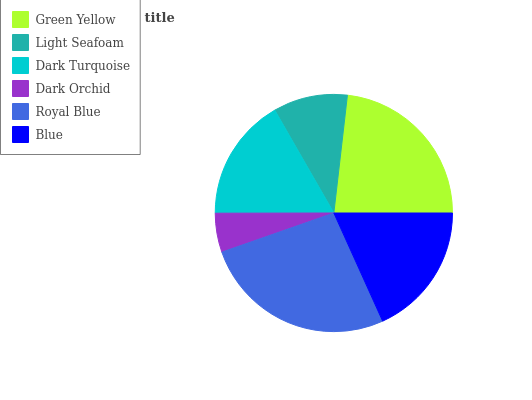Is Dark Orchid the minimum?
Answer yes or no. Yes. Is Royal Blue the maximum?
Answer yes or no. Yes. Is Light Seafoam the minimum?
Answer yes or no. No. Is Light Seafoam the maximum?
Answer yes or no. No. Is Green Yellow greater than Light Seafoam?
Answer yes or no. Yes. Is Light Seafoam less than Green Yellow?
Answer yes or no. Yes. Is Light Seafoam greater than Green Yellow?
Answer yes or no. No. Is Green Yellow less than Light Seafoam?
Answer yes or no. No. Is Blue the high median?
Answer yes or no. Yes. Is Dark Turquoise the low median?
Answer yes or no. Yes. Is Green Yellow the high median?
Answer yes or no. No. Is Green Yellow the low median?
Answer yes or no. No. 